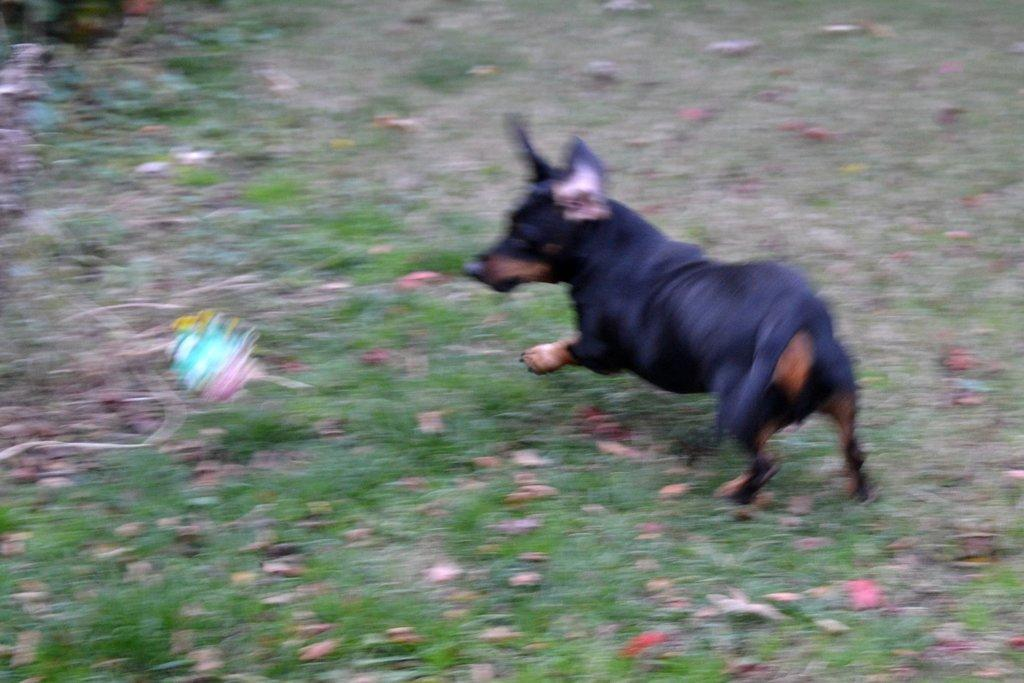What is the main subject of the image? There is a dog in the center of the image. Can you describe the dog's appearance? The dog is black in color. What type of environment is depicted in the image? There is grass at the bottom of the image, suggesting an outdoor setting. What type of apparel is the dog wearing in the image? There is no apparel visible on the dog in the image. Can you see any tanks or military vehicles in the image? There are no tanks or military vehicles present in the image. 